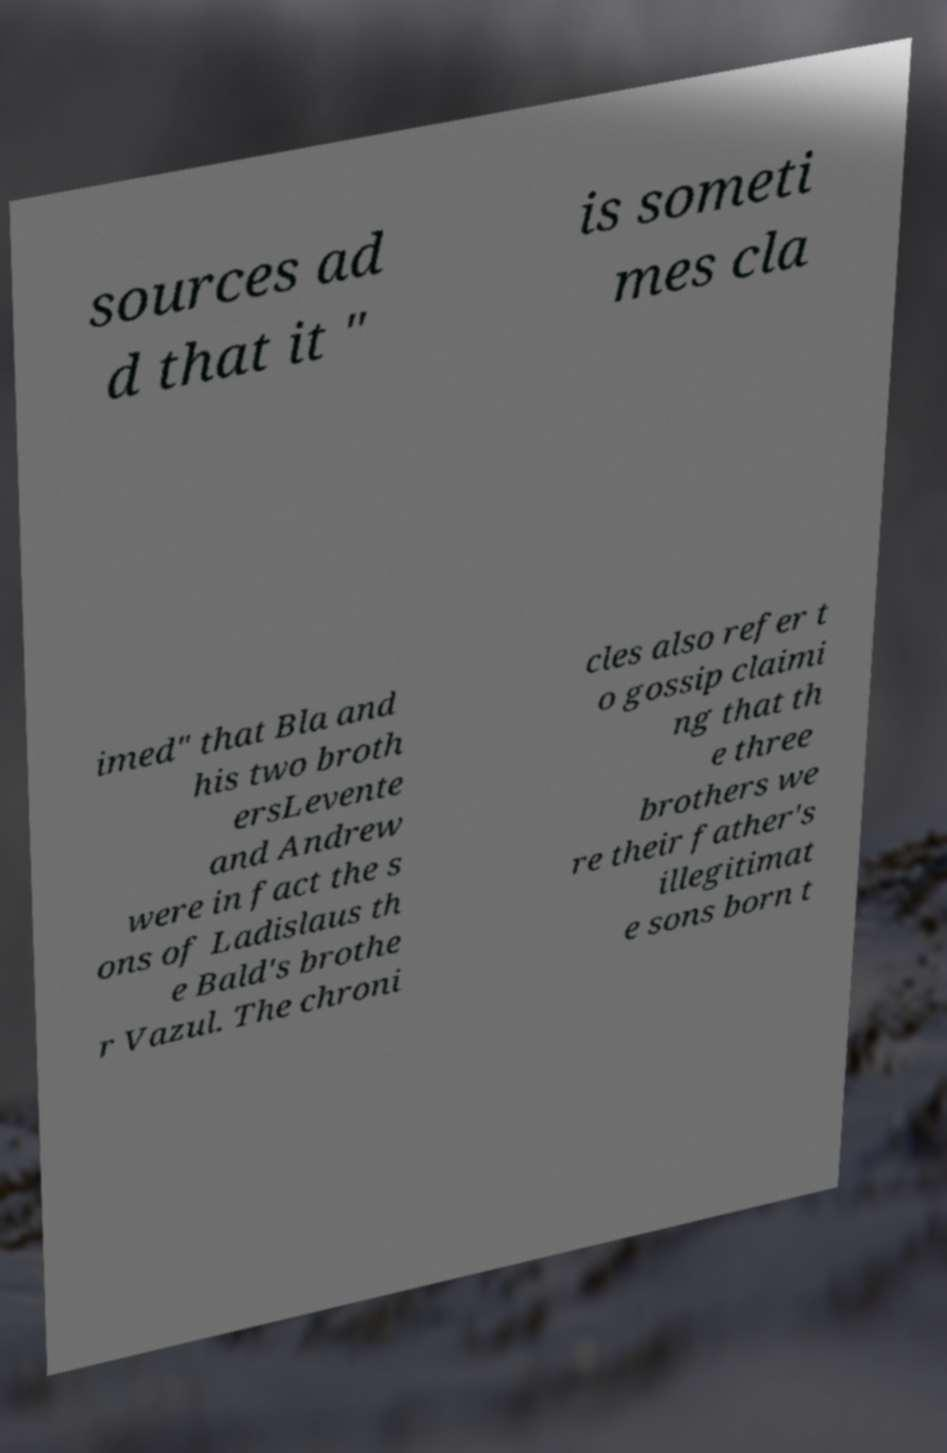Please read and relay the text visible in this image. What does it say? sources ad d that it " is someti mes cla imed" that Bla and his two broth ersLevente and Andrew were in fact the s ons of Ladislaus th e Bald's brothe r Vazul. The chroni cles also refer t o gossip claimi ng that th e three brothers we re their father's illegitimat e sons born t 